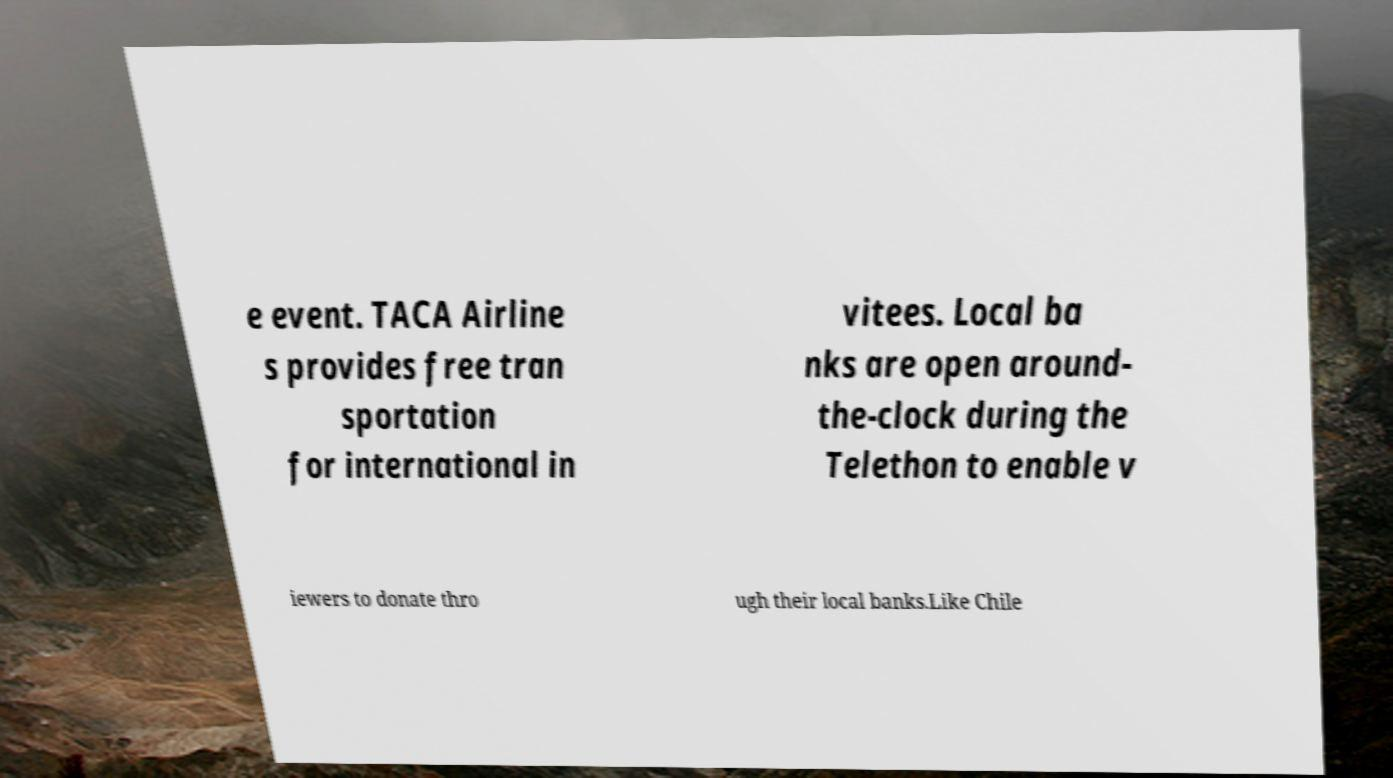For documentation purposes, I need the text within this image transcribed. Could you provide that? e event. TACA Airline s provides free tran sportation for international in vitees. Local ba nks are open around- the-clock during the Telethon to enable v iewers to donate thro ugh their local banks.Like Chile 